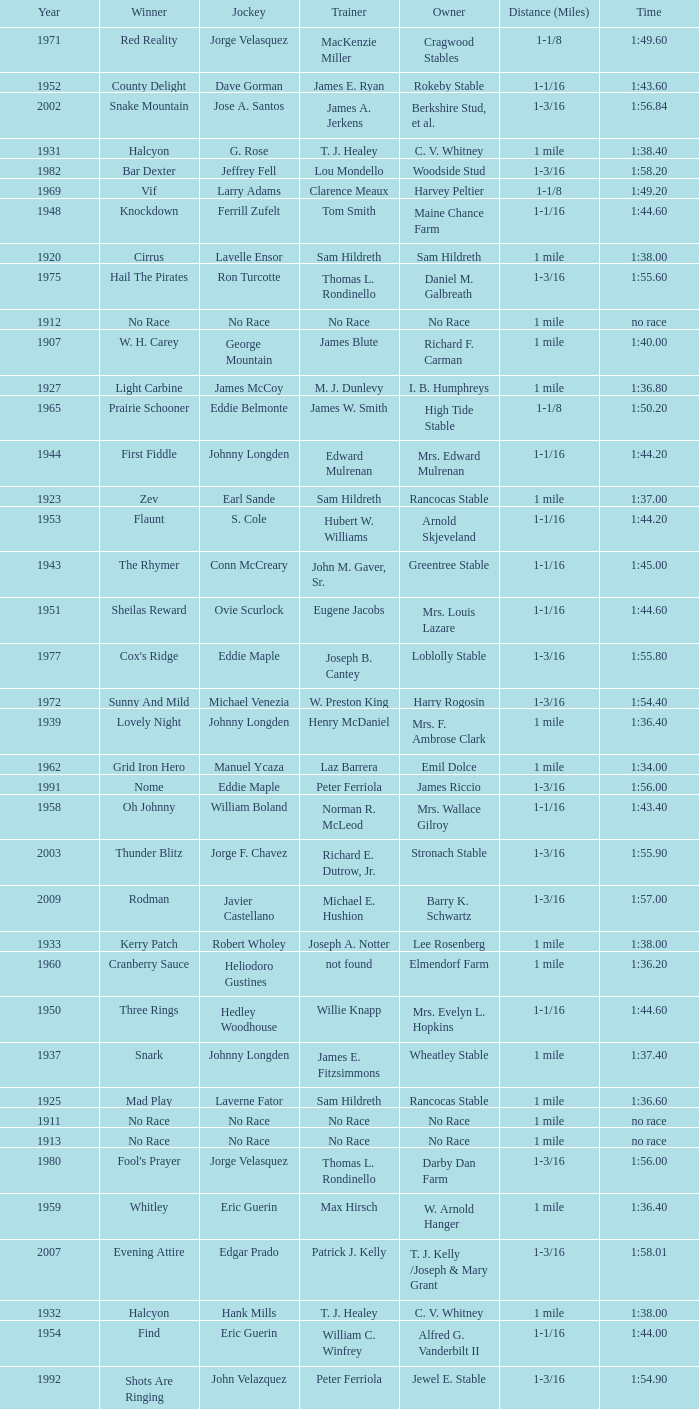When the winner was No Race in a year after 1909, what was the distance? 1 mile, 1 mile, 1 mile. 